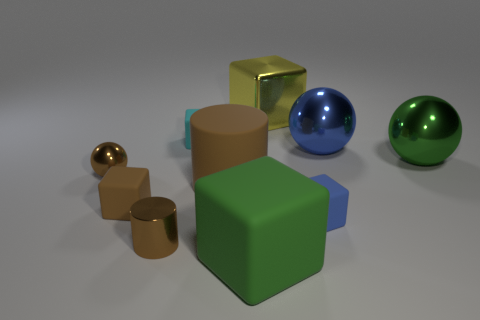What number of objects are big green objects or things to the right of the big yellow shiny block?
Make the answer very short. 4. Are there fewer green spheres than cylinders?
Offer a very short reply. Yes. There is a big metallic thing that is to the right of the blue object behind the brown metallic thing behind the brown matte cylinder; what color is it?
Give a very brief answer. Green. Is the material of the brown ball the same as the brown cube?
Provide a short and direct response. No. What number of large green matte objects are in front of the cyan thing?
Ensure brevity in your answer.  1. What size is the cyan matte object that is the same shape as the small blue thing?
Provide a short and direct response. Small. What number of green things are tiny matte cylinders or large things?
Offer a very short reply. 2. What number of cyan objects are on the left side of the small ball that is behind the large brown matte thing?
Provide a succinct answer. 0. How many other things are there of the same shape as the small blue thing?
Provide a succinct answer. 4. There is a block that is the same color as the tiny shiny cylinder; what is it made of?
Offer a very short reply. Rubber. 